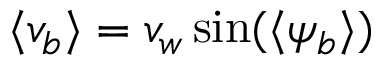Convert formula to latex. <formula><loc_0><loc_0><loc_500><loc_500>\langle v _ { b } \rangle = v _ { w } \sin ( { \langle \psi _ { b } \rangle } )</formula> 